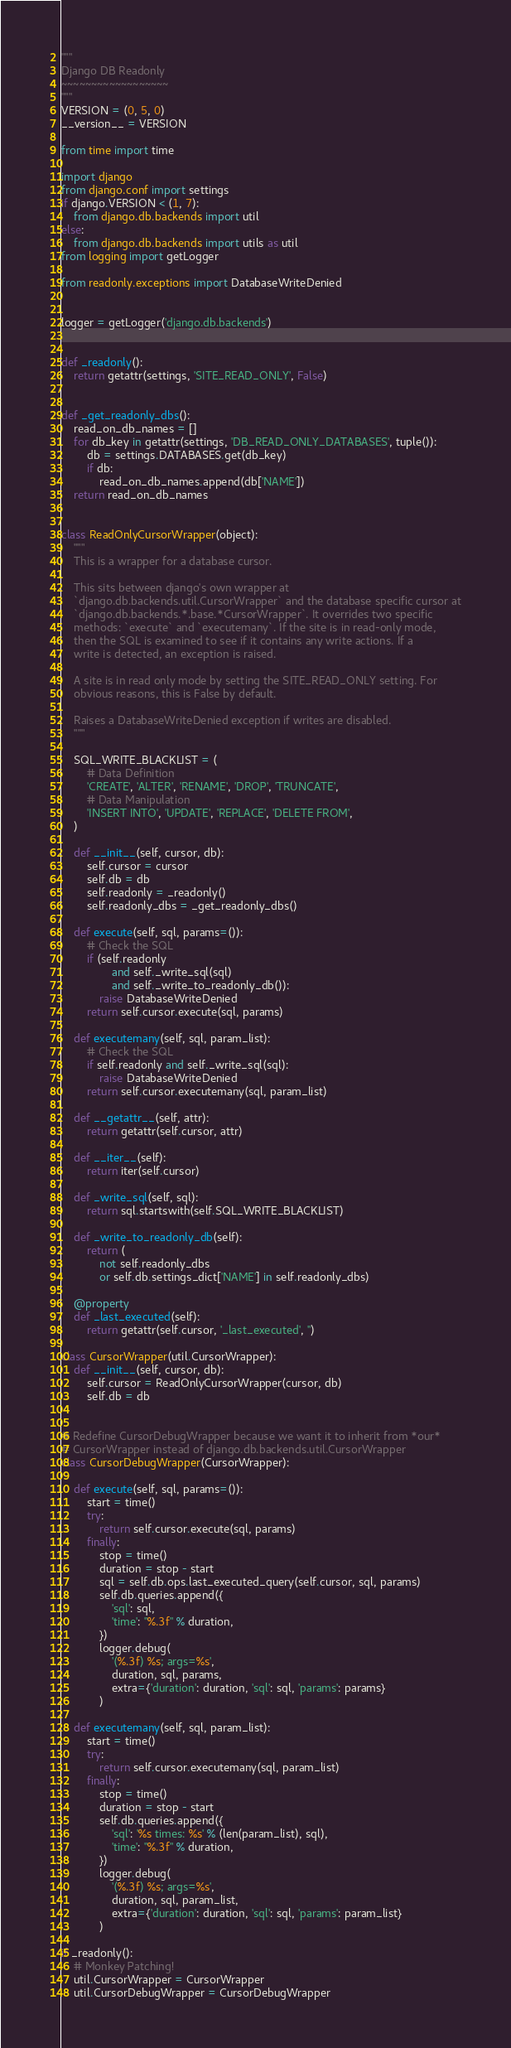<code> <loc_0><loc_0><loc_500><loc_500><_Python_>"""
Django DB Readonly
~~~~~~~~~~~~~~~~~~
"""
VERSION = (0, 5, 0)
__version__ = VERSION

from time import time

import django
from django.conf import settings
if django.VERSION < (1, 7):
    from django.db.backends import util
else:
    from django.db.backends import utils as util
from logging import getLogger

from readonly.exceptions import DatabaseWriteDenied


logger = getLogger('django.db.backends')


def _readonly():
    return getattr(settings, 'SITE_READ_ONLY', False)


def _get_readonly_dbs():
    read_on_db_names = []
    for db_key in getattr(settings, 'DB_READ_ONLY_DATABASES', tuple()):
        db = settings.DATABASES.get(db_key)
        if db:
            read_on_db_names.append(db['NAME'])
    return read_on_db_names


class ReadOnlyCursorWrapper(object):
    """
    This is a wrapper for a database cursor.

    This sits between django's own wrapper at
    `django.db.backends.util.CursorWrapper` and the database specific cursor at
    `django.db.backends.*.base.*CursorWrapper`. It overrides two specific
    methods: `execute` and `executemany`. If the site is in read-only mode,
    then the SQL is examined to see if it contains any write actions. If a
    write is detected, an exception is raised.

    A site is in read only mode by setting the SITE_READ_ONLY setting. For
    obvious reasons, this is False by default.

    Raises a DatabaseWriteDenied exception if writes are disabled.
    """

    SQL_WRITE_BLACKLIST = (
        # Data Definition
        'CREATE', 'ALTER', 'RENAME', 'DROP', 'TRUNCATE',
        # Data Manipulation
        'INSERT INTO', 'UPDATE', 'REPLACE', 'DELETE FROM',
    )

    def __init__(self, cursor, db):
        self.cursor = cursor
        self.db = db
        self.readonly = _readonly()
        self.readonly_dbs = _get_readonly_dbs()

    def execute(self, sql, params=()):
        # Check the SQL
        if (self.readonly
                and self._write_sql(sql)
                and self._write_to_readonly_db()):
            raise DatabaseWriteDenied
        return self.cursor.execute(sql, params)

    def executemany(self, sql, param_list):
        # Check the SQL
        if self.readonly and self._write_sql(sql):
            raise DatabaseWriteDenied
        return self.cursor.executemany(sql, param_list)

    def __getattr__(self, attr):
        return getattr(self.cursor, attr)

    def __iter__(self):
        return iter(self.cursor)

    def _write_sql(self, sql):
        return sql.startswith(self.SQL_WRITE_BLACKLIST)

    def _write_to_readonly_db(self):
        return (
            not self.readonly_dbs
            or self.db.settings_dict['NAME'] in self.readonly_dbs)

    @property
    def _last_executed(self):
        return getattr(self.cursor, '_last_executed', '')

class CursorWrapper(util.CursorWrapper):
    def __init__(self, cursor, db):
        self.cursor = ReadOnlyCursorWrapper(cursor, db)
        self.db = db


# Redefine CursorDebugWrapper because we want it to inherit from *our*
# CursorWrapper instead of django.db.backends.util.CursorWrapper
class CursorDebugWrapper(CursorWrapper):

    def execute(self, sql, params=()):
        start = time()
        try:
            return self.cursor.execute(sql, params)
        finally:
            stop = time()
            duration = stop - start
            sql = self.db.ops.last_executed_query(self.cursor, sql, params)
            self.db.queries.append({
                'sql': sql,
                'time': "%.3f" % duration,
            })
            logger.debug(
                '(%.3f) %s; args=%s',
                duration, sql, params,
                extra={'duration': duration, 'sql': sql, 'params': params}
            )

    def executemany(self, sql, param_list):
        start = time()
        try:
            return self.cursor.executemany(sql, param_list)
        finally:
            stop = time()
            duration = stop - start
            self.db.queries.append({
                'sql': '%s times: %s' % (len(param_list), sql),
                'time': "%.3f" % duration,
            })
            logger.debug(
                '(%.3f) %s; args=%s',
                duration, sql, param_list,
                extra={'duration': duration, 'sql': sql, 'params': param_list}
            )

if _readonly():
    # Monkey Patching!
    util.CursorWrapper = CursorWrapper
    util.CursorDebugWrapper = CursorDebugWrapper
</code> 